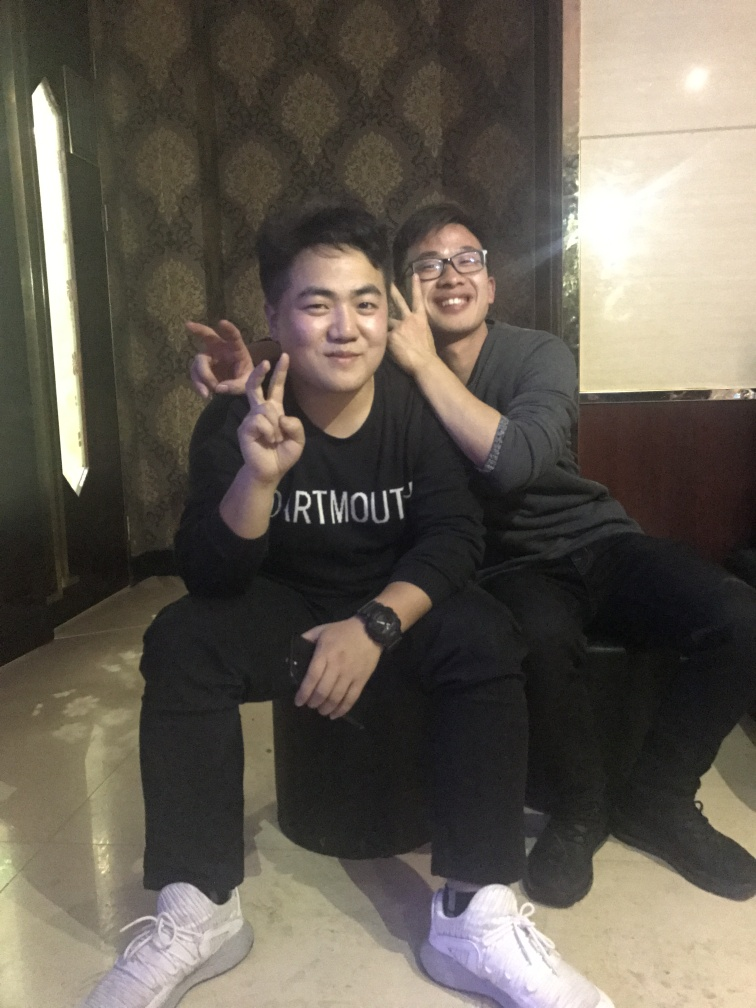Can you describe the atmosphere or mood of the setting where this photo was taken? The photo seems to capture a casual and friendly atmosphere. The two individuals are smiling and making playful gestures, which implies they are in a relaxed social setting, possibly enjoying an informal gathering or outing. 